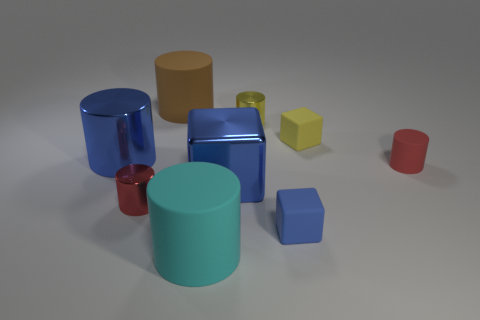Subtract all large brown rubber cylinders. How many cylinders are left? 5 Subtract all cyan cylinders. How many cylinders are left? 5 Subtract all blue cylinders. Subtract all purple blocks. How many cylinders are left? 5 Subtract all cylinders. How many objects are left? 3 Subtract all small things. Subtract all metallic things. How many objects are left? 0 Add 9 small blue matte objects. How many small blue matte objects are left? 10 Add 7 large cyan matte balls. How many large cyan matte balls exist? 7 Subtract 1 brown cylinders. How many objects are left? 8 